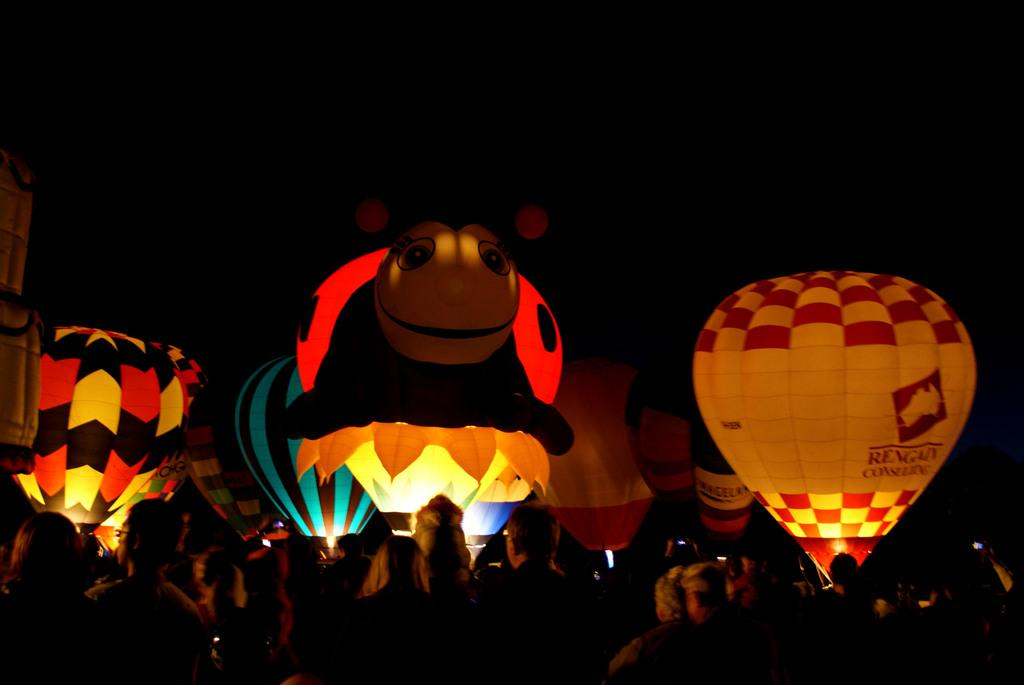How many people are in the image? There is a group of persons in the image. What are the people doing in the image? Some of the persons are flying hot air balloons. What can be observed about the hot air balloons? The hot air balloons are in different colors and are on the ground. What is the color of the background in the image? The background of the image is dark in color. How much does the rake weigh in the image? There is no rake present in the image. Can you see any mountains in the background of the image? There are no mountains visible in the image; the background is dark in color. 